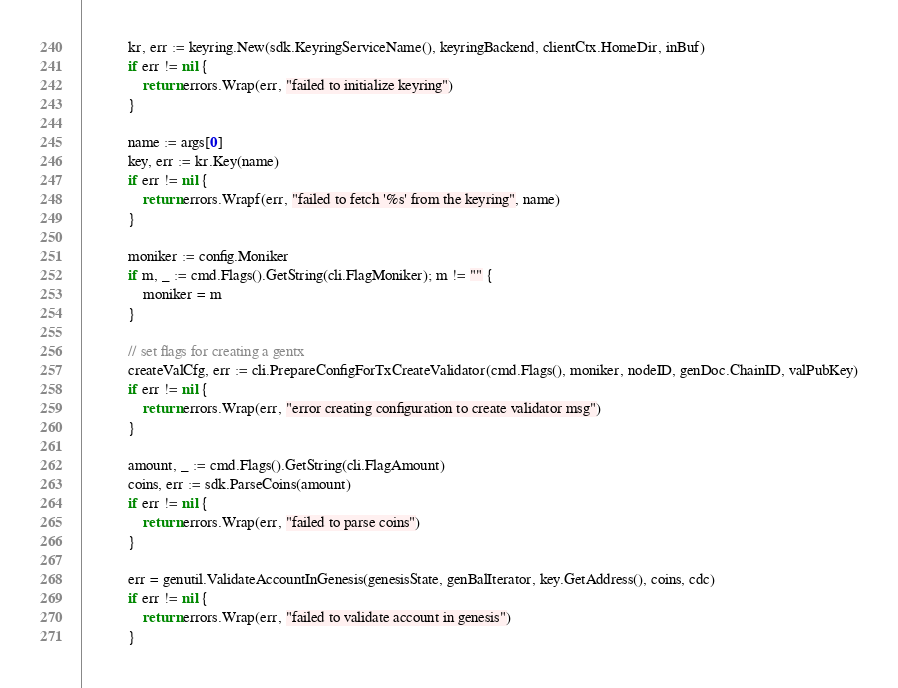Convert code to text. <code><loc_0><loc_0><loc_500><loc_500><_Go_>
			kr, err := keyring.New(sdk.KeyringServiceName(), keyringBackend, clientCtx.HomeDir, inBuf)
			if err != nil {
				return errors.Wrap(err, "failed to initialize keyring")
			}

			name := args[0]
			key, err := kr.Key(name)
			if err != nil {
				return errors.Wrapf(err, "failed to fetch '%s' from the keyring", name)
			}

			moniker := config.Moniker
			if m, _ := cmd.Flags().GetString(cli.FlagMoniker); m != "" {
				moniker = m
			}

			// set flags for creating a gentx
			createValCfg, err := cli.PrepareConfigForTxCreateValidator(cmd.Flags(), moniker, nodeID, genDoc.ChainID, valPubKey)
			if err != nil {
				return errors.Wrap(err, "error creating configuration to create validator msg")
			}

			amount, _ := cmd.Flags().GetString(cli.FlagAmount)
			coins, err := sdk.ParseCoins(amount)
			if err != nil {
				return errors.Wrap(err, "failed to parse coins")
			}

			err = genutil.ValidateAccountInGenesis(genesisState, genBalIterator, key.GetAddress(), coins, cdc)
			if err != nil {
				return errors.Wrap(err, "failed to validate account in genesis")
			}
</code> 